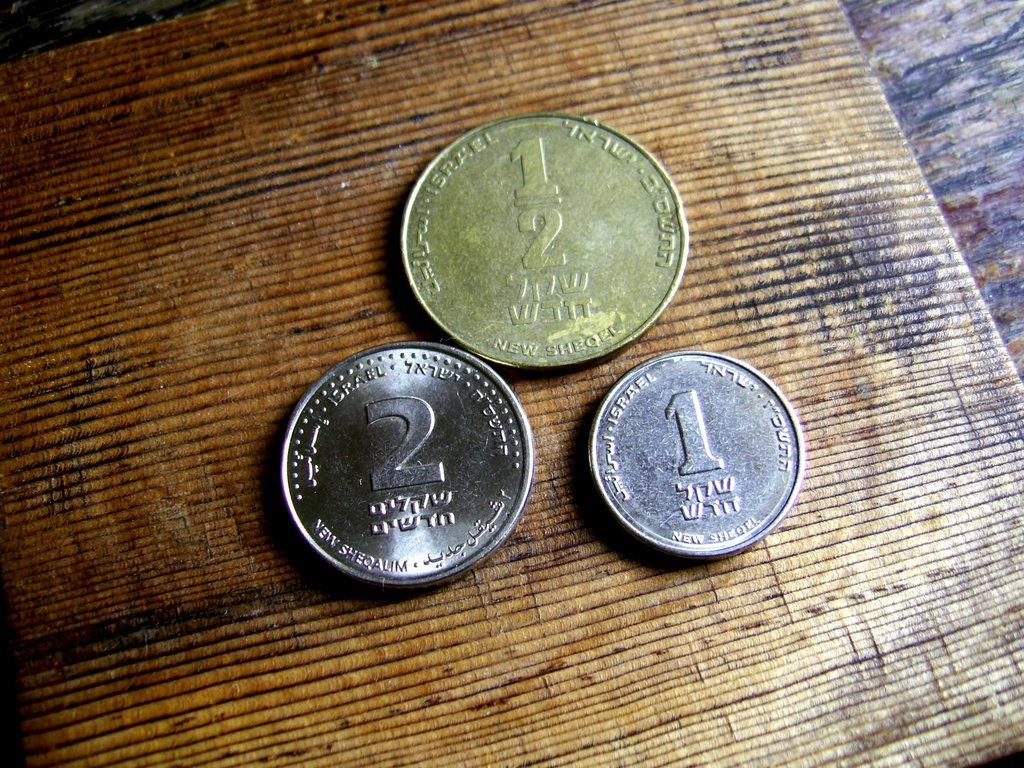What objects are in the center of the image? There are three coins in the center of the image. Can you describe the background of the image? There is a table in the background of the image. What type of soap is being used to clean the machine in the image? There is no soap or machine present in the image; it only features three coins and a table in the background. 